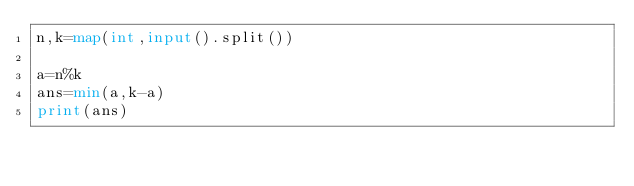Convert code to text. <code><loc_0><loc_0><loc_500><loc_500><_Python_>n,k=map(int,input().split())

a=n%k
ans=min(a,k-a)
print(ans)</code> 